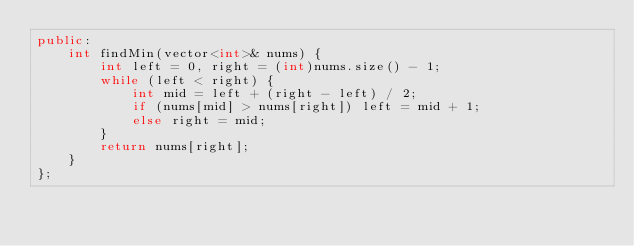Convert code to text. <code><loc_0><loc_0><loc_500><loc_500><_C++_>public:
    int findMin(vector<int>& nums) {
        int left = 0, right = (int)nums.size() - 1;
        while (left < right) {
            int mid = left + (right - left) / 2;
            if (nums[mid] > nums[right]) left = mid + 1;
            else right = mid;
        }
        return nums[right];
    }
};</code> 